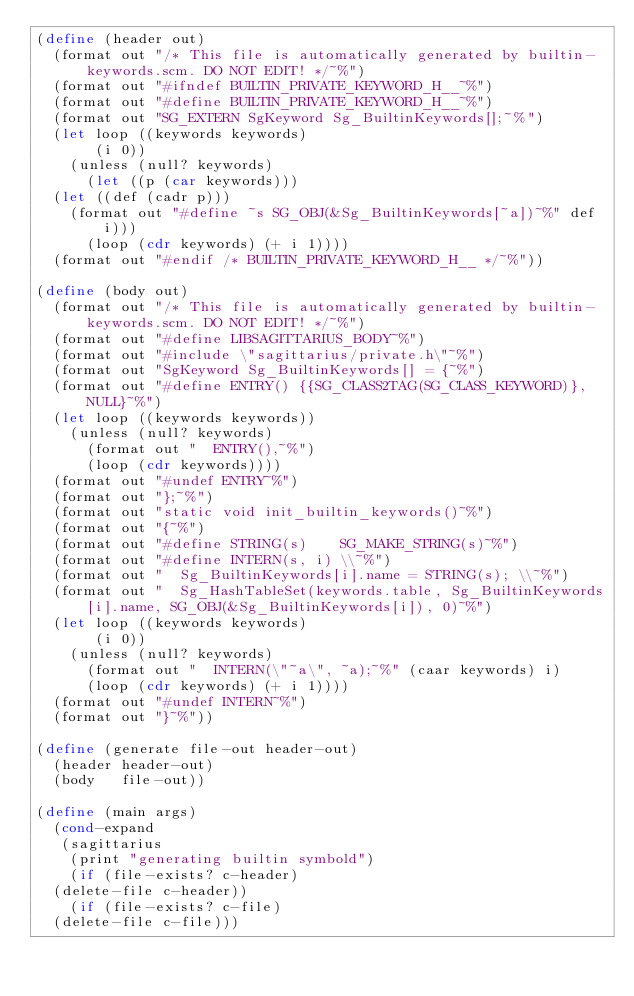<code> <loc_0><loc_0><loc_500><loc_500><_Scheme_>(define (header out)
  (format out "/* This file is automatically generated by builtin-keywords.scm. DO NOT EDIT! */~%")
  (format out "#ifndef BUILTIN_PRIVATE_KEYWORD_H__~%")
  (format out "#define BUILTIN_PRIVATE_KEYWORD_H__~%")
  (format out "SG_EXTERN SgKeyword Sg_BuiltinKeywords[];~%")
  (let loop ((keywords keywords)
	     (i 0))
    (unless (null? keywords)
      (let ((p (car keywords)))
	(let ((def (cadr p)))
	  (format out "#define ~s SG_OBJ(&Sg_BuiltinKeywords[~a])~%" def i)))
      (loop (cdr keywords) (+ i 1))))
  (format out "#endif /* BUILTIN_PRIVATE_KEYWORD_H__ */~%"))

(define (body out)
  (format out "/* This file is automatically generated by builtin-keywords.scm. DO NOT EDIT! */~%")
  (format out "#define LIBSAGITTARIUS_BODY~%")
  (format out "#include \"sagittarius/private.h\"~%")
  (format out "SgKeyword Sg_BuiltinKeywords[] = {~%")
  (format out "#define ENTRY() {{SG_CLASS2TAG(SG_CLASS_KEYWORD)}, NULL}~%")
  (let loop ((keywords keywords))
    (unless (null? keywords)
      (format out "  ENTRY(),~%")
      (loop (cdr keywords))))
  (format out "#undef ENTRY~%")
  (format out "};~%")
  (format out "static void init_builtin_keywords()~%")
  (format out "{~%")
  (format out "#define STRING(s)    SG_MAKE_STRING(s)~%")
  (format out "#define INTERN(s, i) \\~%")
  (format out "  Sg_BuiltinKeywords[i].name = STRING(s); \\~%")
  (format out "  Sg_HashTableSet(keywords.table, Sg_BuiltinKeywords[i].name, SG_OBJ(&Sg_BuiltinKeywords[i]), 0)~%")
  (let loop ((keywords keywords)
	     (i 0))
    (unless (null? keywords)
      (format out "  INTERN(\"~a\", ~a);~%" (caar keywords) i)
      (loop (cdr keywords) (+ i 1))))
  (format out "#undef INTERN~%")
  (format out "}~%"))
  
(define (generate file-out header-out)
  (header header-out)
  (body   file-out))
  
(define (main args)
  (cond-expand
   (sagittarius
    (print "generating builtin symbold")
    (if (file-exists? c-header)
	(delete-file c-header))
    (if (file-exists? c-file)
	(delete-file c-file)))</code> 